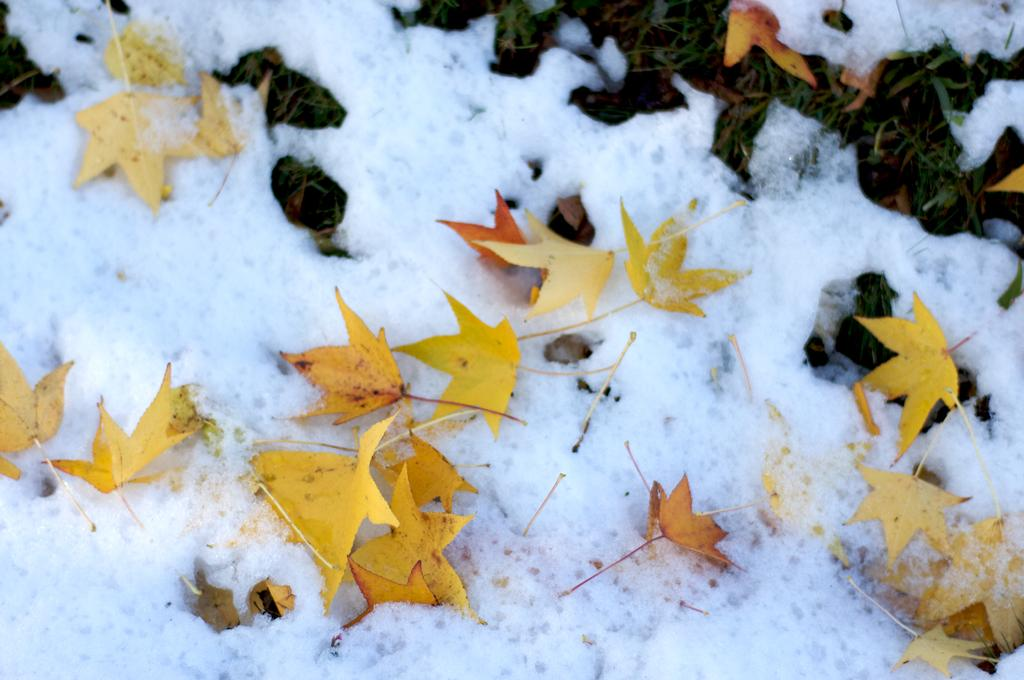What colors are the leaves in the image? The leaves in the image are yellow and orange. Where are the leaves located in the image? The leaves are on the snow. What type of vegetation is visible on the ground in the image? There is grass visible on the ground. How many tickets does the daughter have in the image? There is no daughter or tickets present in the image. 